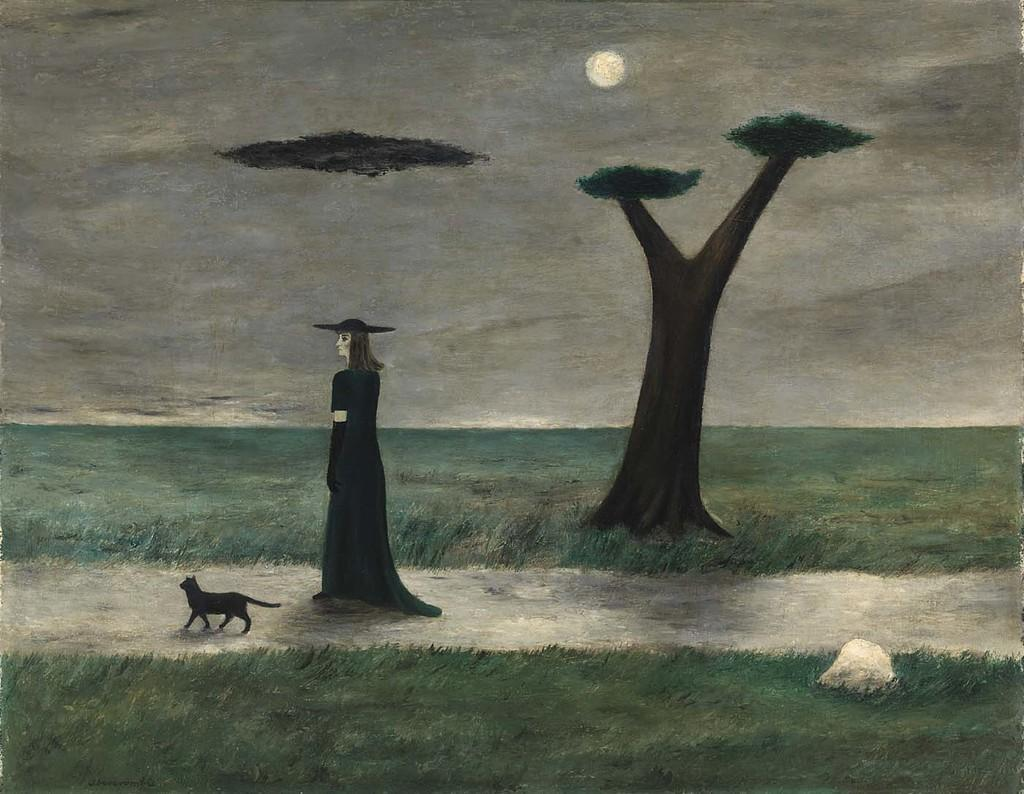What is the main subject of the image? There is a painting in the image. What is depicted in the painting? The painting depicts a grassland with a path. Are there any animals or people in the painting? Yes, there is a cat and a woman on the path in the painting. What can be seen in the background of the painting? There is a tree and the sky visible in the background of the painting. How does the woman in the painting help her child swim in the grassland? There is no child or swimming activity depicted in the painting; it only shows a woman and a cat on a path in a grassland. 